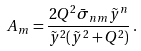<formula> <loc_0><loc_0><loc_500><loc_500>A _ { m } = \frac { 2 Q ^ { 2 } \bar { \sigma } _ { n m } \tilde { y } ^ { n } } { \tilde { y } ^ { 2 } ( \tilde { y } ^ { 2 } + Q ^ { 2 } ) } \, .</formula> 